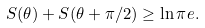Convert formula to latex. <formula><loc_0><loc_0><loc_500><loc_500>S ( \theta ) + S ( \theta + \pi / 2 ) \geq \ln \pi e .</formula> 